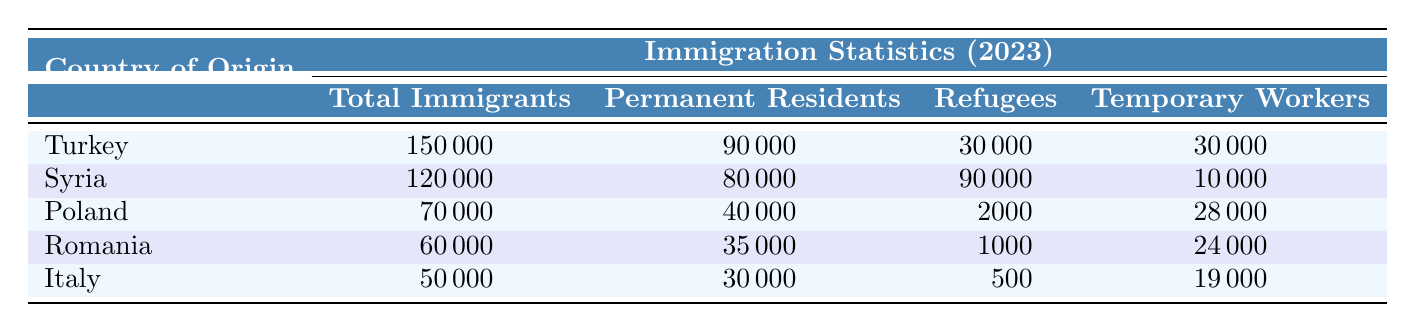What is the total number of immigrants from Turkey in 2023? Referring to the table, Turkey has a total of 150000 immigrants listed for the year 2023.
Answer: 150000 How many permanent residents are there from Syria? The table shows that there are 80000 permanent residents from Syria in 2023.
Answer: 80000 Which country has the highest number of refugees in Germany in 2023? By comparing the refugee numbers: Turkey has 30000, Syria has 90000, Poland has 2000, Romania has 1000, and Italy has 500. The highest number is from Syria with 90000.
Answer: Syria What is the difference in total immigrants between Turkey and Poland? Turkey has 150000 immigrants and Poland has 70000 immigrants. The difference is 150000 - 70000 = 80000.
Answer: 80000 Are there more temporary workers from Italy than from Romania? According to the table, Italy has 19000 temporary workers and Romania has 24000. Since 19000 is less than 24000, the answer is no.
Answer: No What is the average number of permanent residents from the listed countries? The permanent residents are: Turkey 90000, Syria 80000, Poland 40000, Romania 35000, and Italy 30000. Summing these gives 90000 + 80000 + 40000 + 35000 + 30000 = 275000. Since there are 5 countries, the average is 275000 / 5 = 55000.
Answer: 55000 Which country has the least number of total immigrants? Looking at the total immigrant numbers: Turkey 150000, Syria 120000, Poland 70000, Romania 60000, and Italy 50000. The least number is from Italy with 50000.
Answer: Italy How many total immigrants are there from Poland and Romania combined? Poland has 70000 immigrants and Romania has 60000. Adding these gives 70000 + 60000 = 130000 for the combined total.
Answer: 130000 Are there more refugees in Turkey than in Poland? The refugee numbers are: Turkey 30000 and Poland 2000. Since 30000 is greater than 2000, the answer is yes.
Answer: Yes 